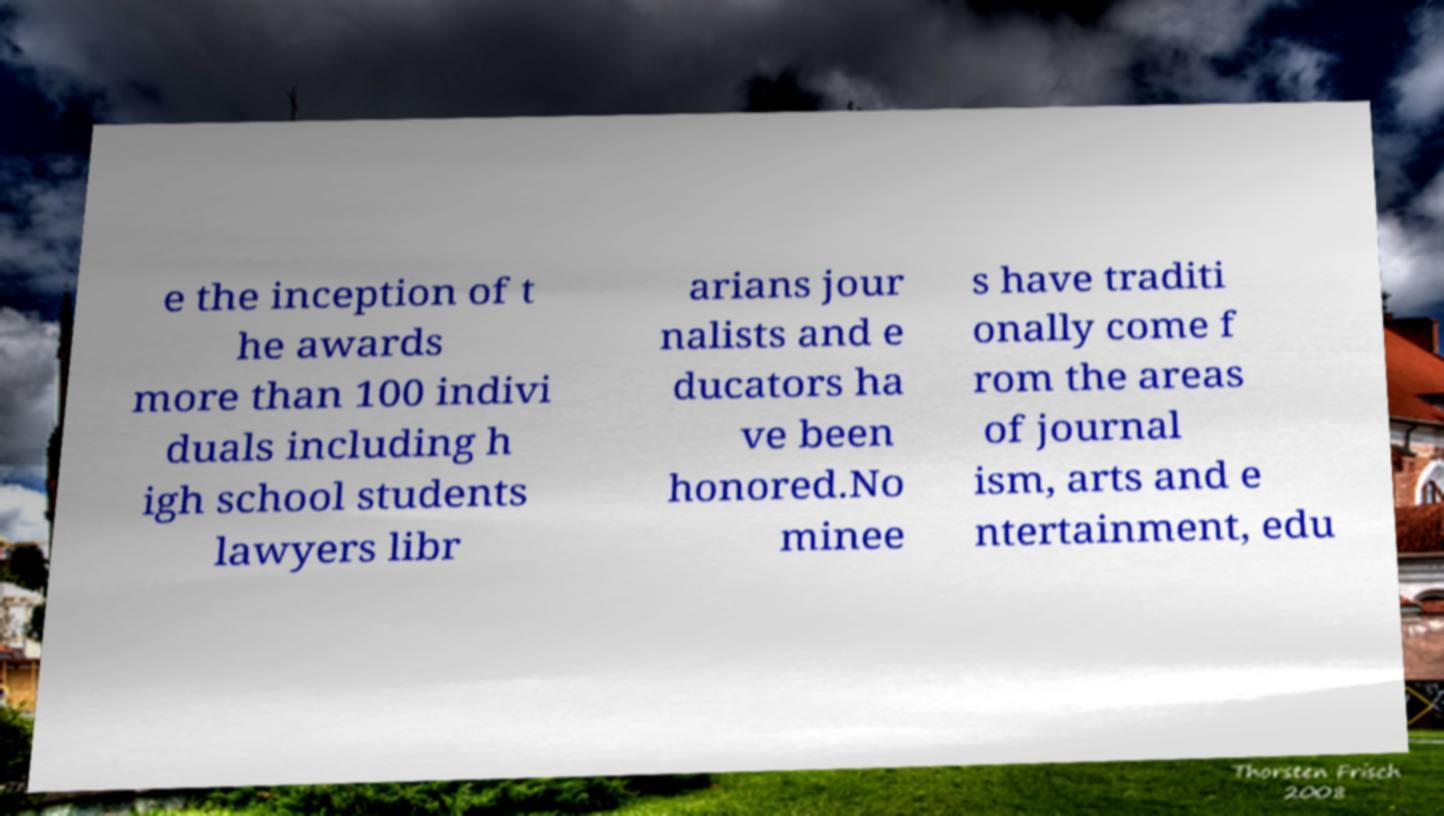Can you accurately transcribe the text from the provided image for me? e the inception of t he awards more than 100 indivi duals including h igh school students lawyers libr arians jour nalists and e ducators ha ve been honored.No minee s have traditi onally come f rom the areas of journal ism, arts and e ntertainment, edu 